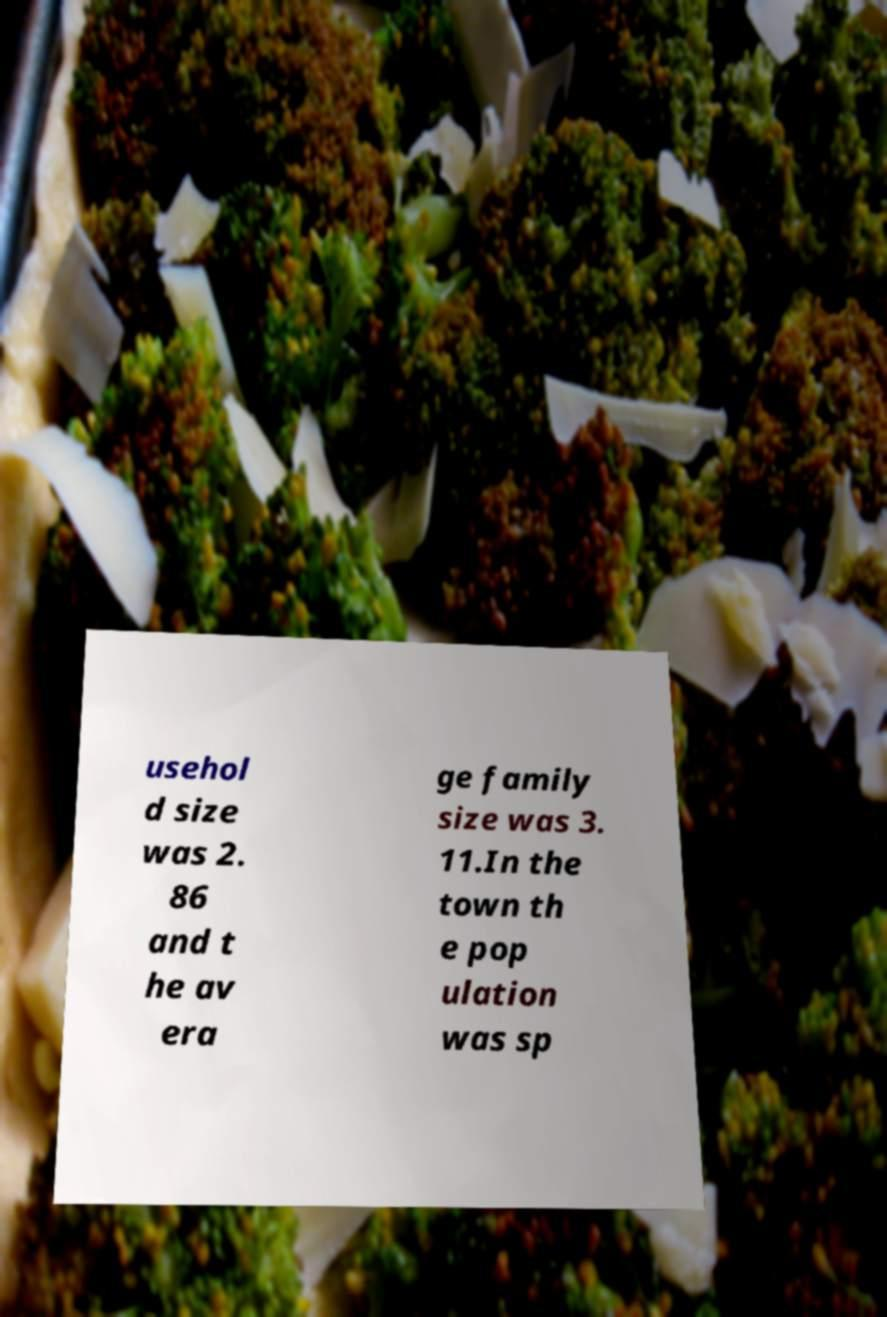Please identify and transcribe the text found in this image. usehol d size was 2. 86 and t he av era ge family size was 3. 11.In the town th e pop ulation was sp 